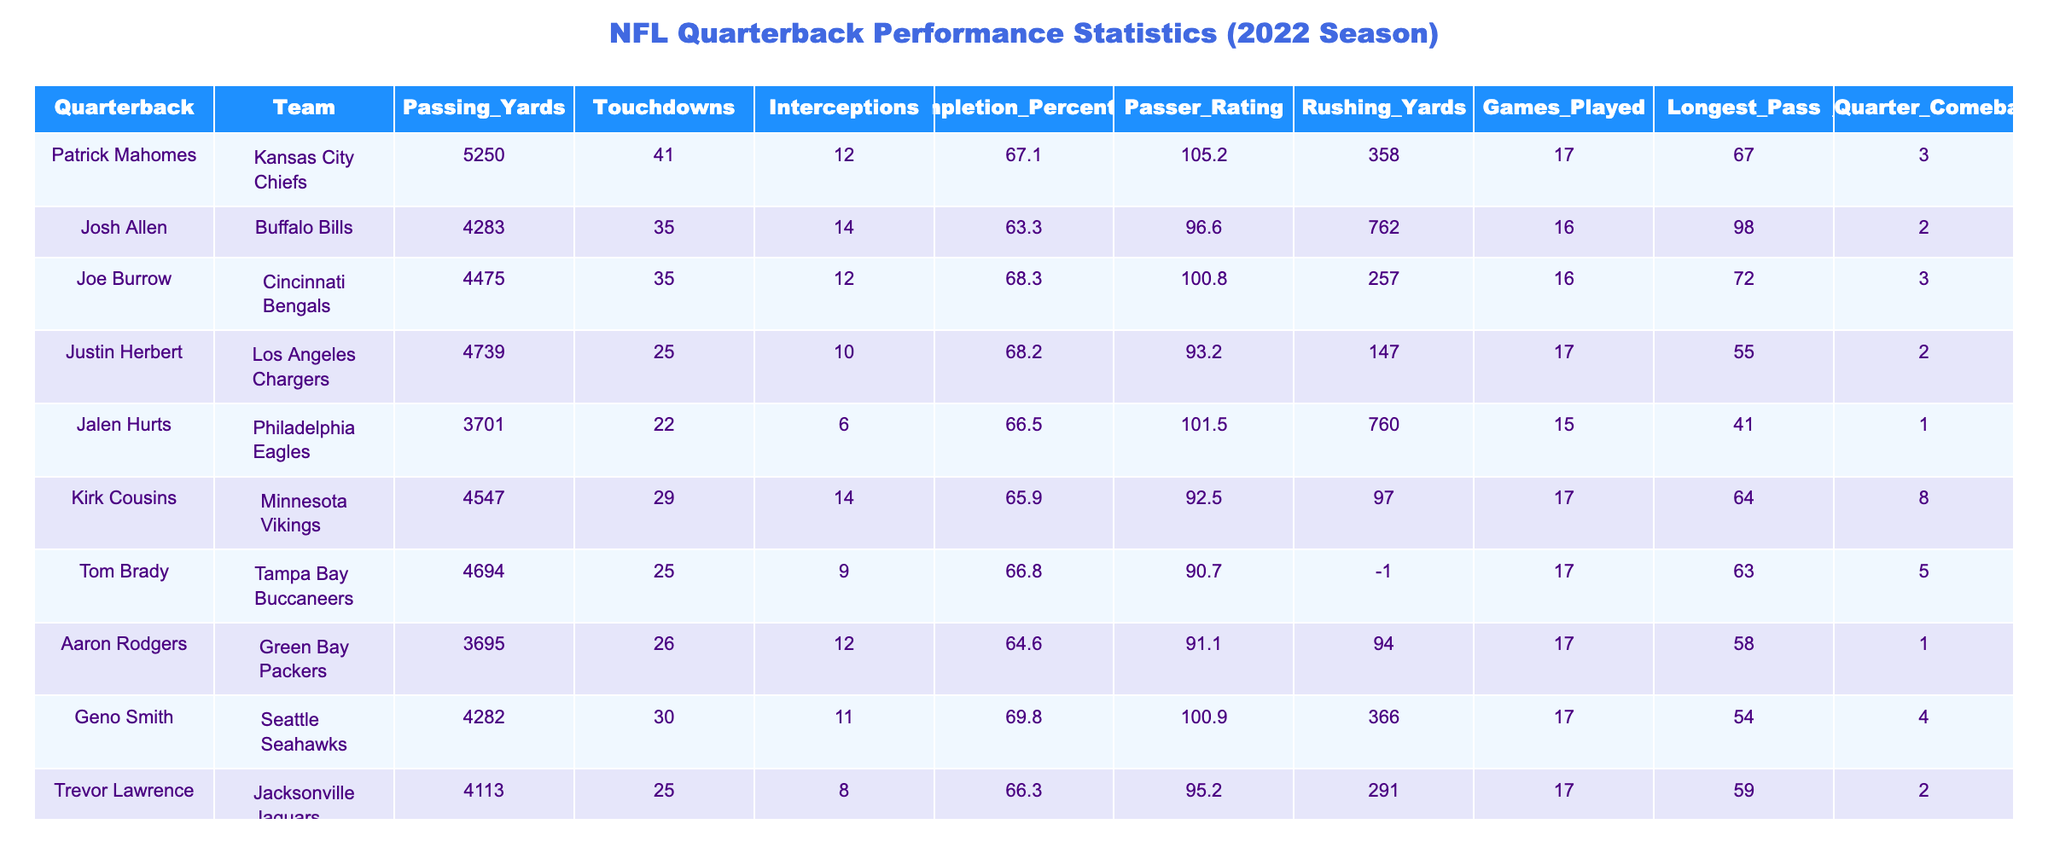What is the passing yardage of Patrick Mahomes? The table includes a specific row for Patrick Mahomes, where the value listed under Passing Yards is 5250.
Answer: 5250 Who threw the most touchdowns in the 2022 season? By comparing the Touchdowns column, Patrick Mahomes leads with 41 touchdowns, which is the highest in the table.
Answer: 41 What is the average passer rating of the quarterbacks listed? The Passer Rating values are 105.2, 96.6, 100.8, 93.2, 101.5, 92.5, 90.7, 91.1, 100.9, and 95.2. Adding these values gives a total of  1001.5, and dividing by 10 (number of quarterbacks) results in an average of 100.15.
Answer: 100.15 Did any quarterback have a completion percentage of over 68%? Looking at the Completion Percentage column, both Patrick Mahomes (67.1) and Joe Burrow (68.3) are the only ones surpassing 68%, confirming that yes, there were quarterbacks with over 68%.
Answer: Yes Which quarterback has the highest rushing yards, and how many did they have? By examining the Rushing Yards column, Josh Allen has the highest total with 762 rushing yards.
Answer: Josh Allen, 762 How many touchdowns did Kirk Cousins throw compared to Tom Brady? Kirk Cousins threw 29 touchdowns, while Tom Brady threw 25 touchdowns. The difference in their touchdowns is 29 - 25 = 4.
Answer: 4 Which quarterback had the most 4th Quarter Comebacks? The 4th Quarter Comebacks column shows that Kirk Cousins led with 8 comebacks, which is more than any other quarterback in the table.
Answer: Kirk Cousins What is the total number of passing yards by the quarterbacks from the AFC? The quarterbacks from the AFC listed are Patrick Mahomes, Joe Burrow, Justin Herbert, and Josh Allen. Their passing yards add up to 5250 + 4475 + 4739 + 4283 = 18747.
Answer: 18747 Is there any quarterback with more interceptions than touchdown passes? By comparing the Touchdowns and Interceptions columns, it's clear that Josh Allen (14 interceptions, 35 touchdowns) and Kirk Cousins (14 interceptions, 29 touchdowns) have more interceptions than touchdowns. Therefore, this statement is false.
Answer: No How does Jalen Hurts' passer rating compare to that of Aaron Rodgers? Jalen Hurts has a Passer Rating of 101.5, while Aaron Rodgers has a rating of 91.1. This shows that Jalen Hurts has a higher rating by subtracting 101.5 - 91.1 = 10.4.
Answer: Jalen Hurts' is higher by 10.4 